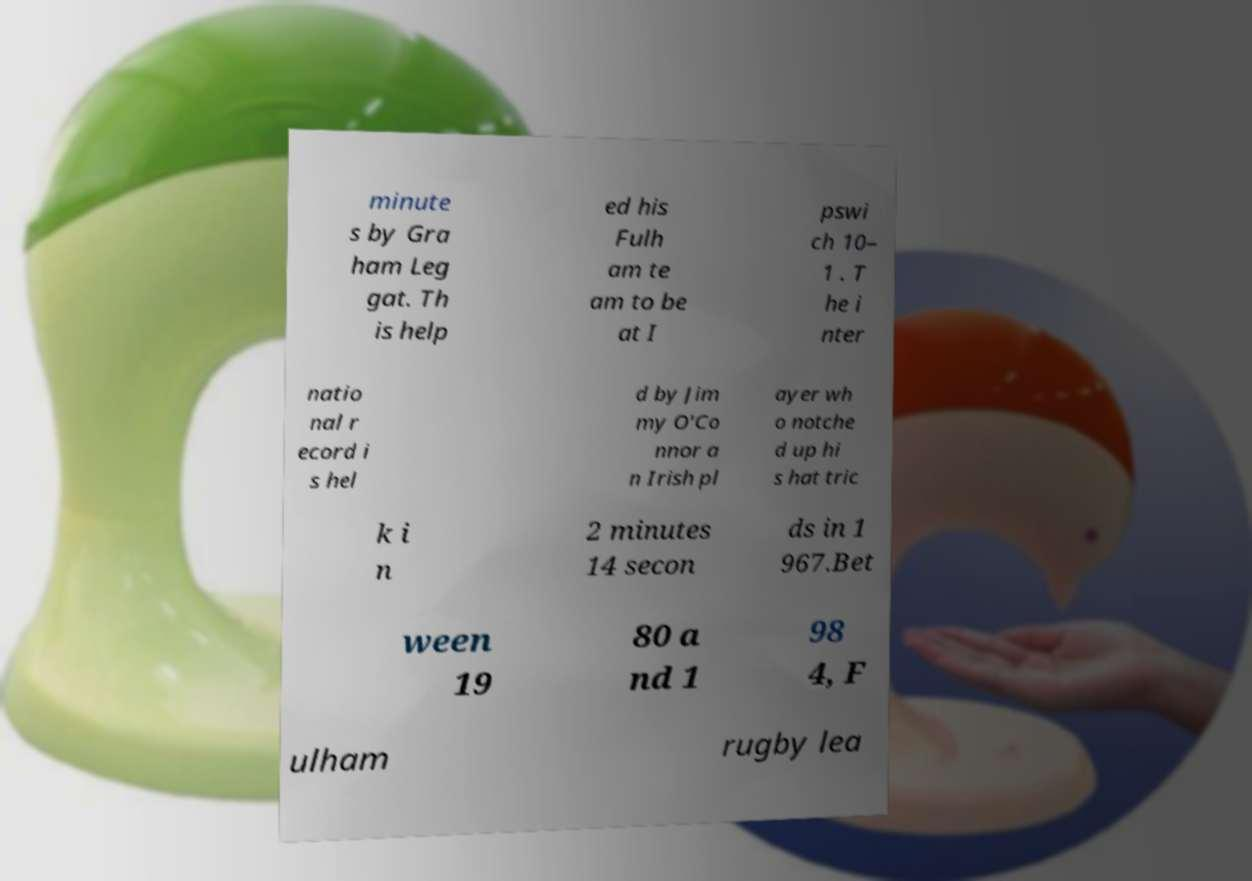For documentation purposes, I need the text within this image transcribed. Could you provide that? minute s by Gra ham Leg gat. Th is help ed his Fulh am te am to be at I pswi ch 10– 1 . T he i nter natio nal r ecord i s hel d by Jim my O'Co nnor a n Irish pl ayer wh o notche d up hi s hat tric k i n 2 minutes 14 secon ds in 1 967.Bet ween 19 80 a nd 1 98 4, F ulham rugby lea 